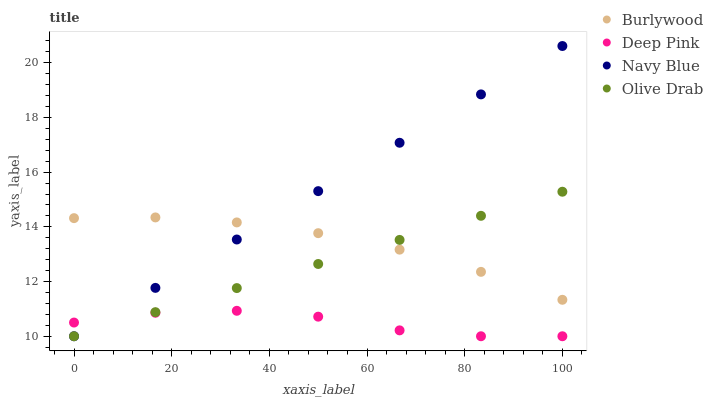Does Deep Pink have the minimum area under the curve?
Answer yes or no. Yes. Does Navy Blue have the maximum area under the curve?
Answer yes or no. Yes. Does Navy Blue have the minimum area under the curve?
Answer yes or no. No. Does Deep Pink have the maximum area under the curve?
Answer yes or no. No. Is Olive Drab the smoothest?
Answer yes or no. Yes. Is Deep Pink the roughest?
Answer yes or no. Yes. Is Navy Blue the smoothest?
Answer yes or no. No. Is Navy Blue the roughest?
Answer yes or no. No. Does Navy Blue have the lowest value?
Answer yes or no. Yes. Does Navy Blue have the highest value?
Answer yes or no. Yes. Does Deep Pink have the highest value?
Answer yes or no. No. Is Deep Pink less than Burlywood?
Answer yes or no. Yes. Is Burlywood greater than Deep Pink?
Answer yes or no. Yes. Does Olive Drab intersect Navy Blue?
Answer yes or no. Yes. Is Olive Drab less than Navy Blue?
Answer yes or no. No. Is Olive Drab greater than Navy Blue?
Answer yes or no. No. Does Deep Pink intersect Burlywood?
Answer yes or no. No. 